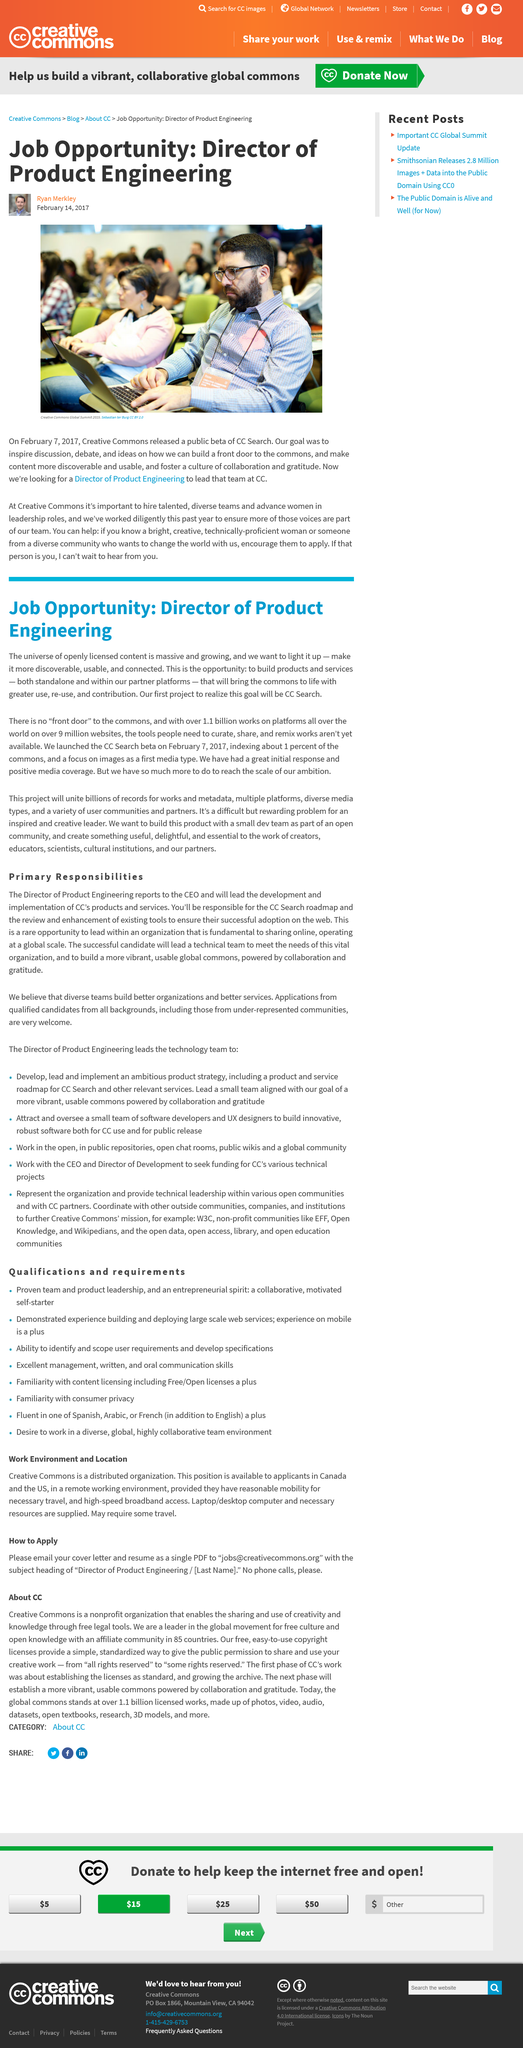Highlight a few significant elements in this photo. The Director or Product Engineering will work on the development of a product as part of the CC Search. The picture was taken at the Creative Commons Global Summit. Approximately 1% of the commons has been indexed. I am looking for a job opportunity with a company that is currently hiring. The text is about the job title of Director or Product Engineering. 